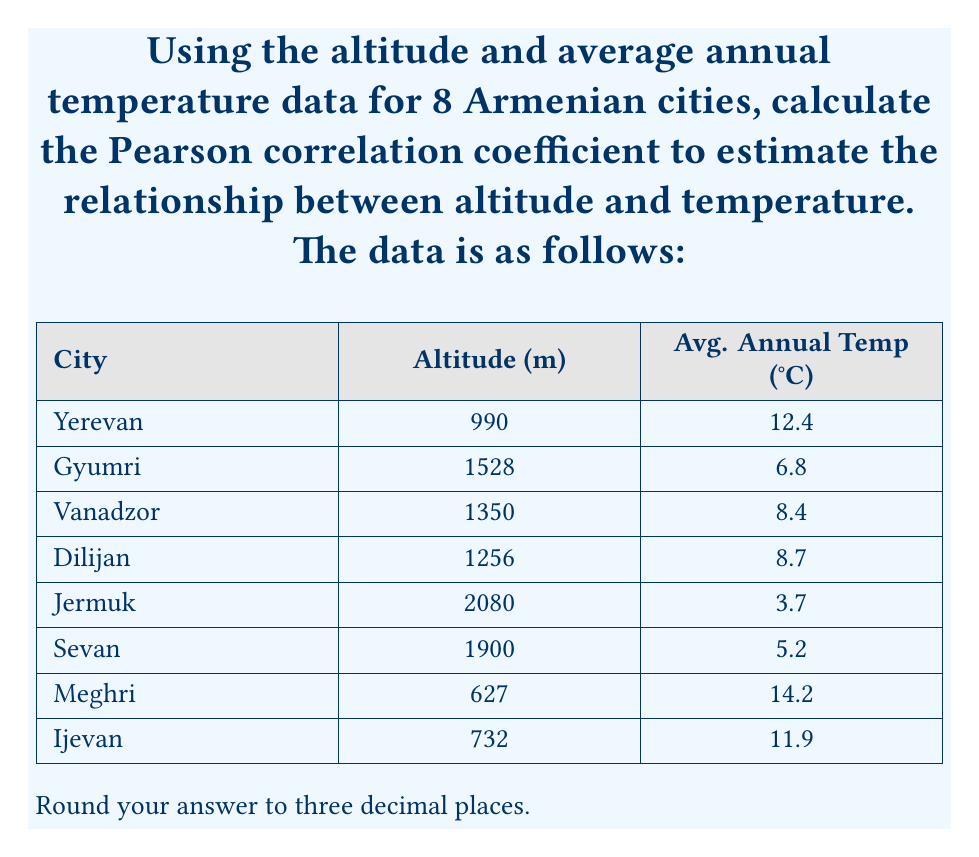Teach me how to tackle this problem. To calculate the Pearson correlation coefficient between altitude and temperature, we'll use the formula:

$$ r = \frac{\sum_{i=1}^{n} (x_i - \bar{x})(y_i - \bar{y})}{\sqrt{\sum_{i=1}^{n} (x_i - \bar{x})^2 \sum_{i=1}^{n} (y_i - \bar{y})^2}} $$

Where:
$x_i$ = altitude values
$y_i$ = temperature values
$\bar{x}$ = mean altitude
$\bar{y}$ = mean temperature
$n$ = number of cities (8)

Step 1: Calculate means
$\bar{x} = \frac{990 + 1528 + 1350 + 1256 + 2080 + 1900 + 627 + 732}{8} = 1307.875$ m
$\bar{y} = \frac{12.4 + 6.8 + 8.4 + 8.7 + 3.7 + 5.2 + 14.2 + 11.9}{8} = 8.9125$ °C

Step 2: Calculate $(x_i - \bar{x})$, $(y_i - \bar{y})$, $(x_i - \bar{x})^2$, $(y_i - \bar{y})^2$, and $(x_i - \bar{x})(y_i - \bar{y})$ for each city.

Step 3: Sum up the results:
$\sum (x_i - \bar{x})(y_i - \bar{y}) = -1,026,703.28125$
$\sum (x_i - \bar{x})^2 = 2,305,300.84375$
$\sum (y_i - \bar{y})^2 = 118.109375$

Step 4: Apply the formula:

$$ r = \frac{-1,026,703.28125}{\sqrt{2,305,300.84375 \times 118.109375}} = -0.89298 $$

Step 5: Round to three decimal places: -0.893
Answer: -0.893 